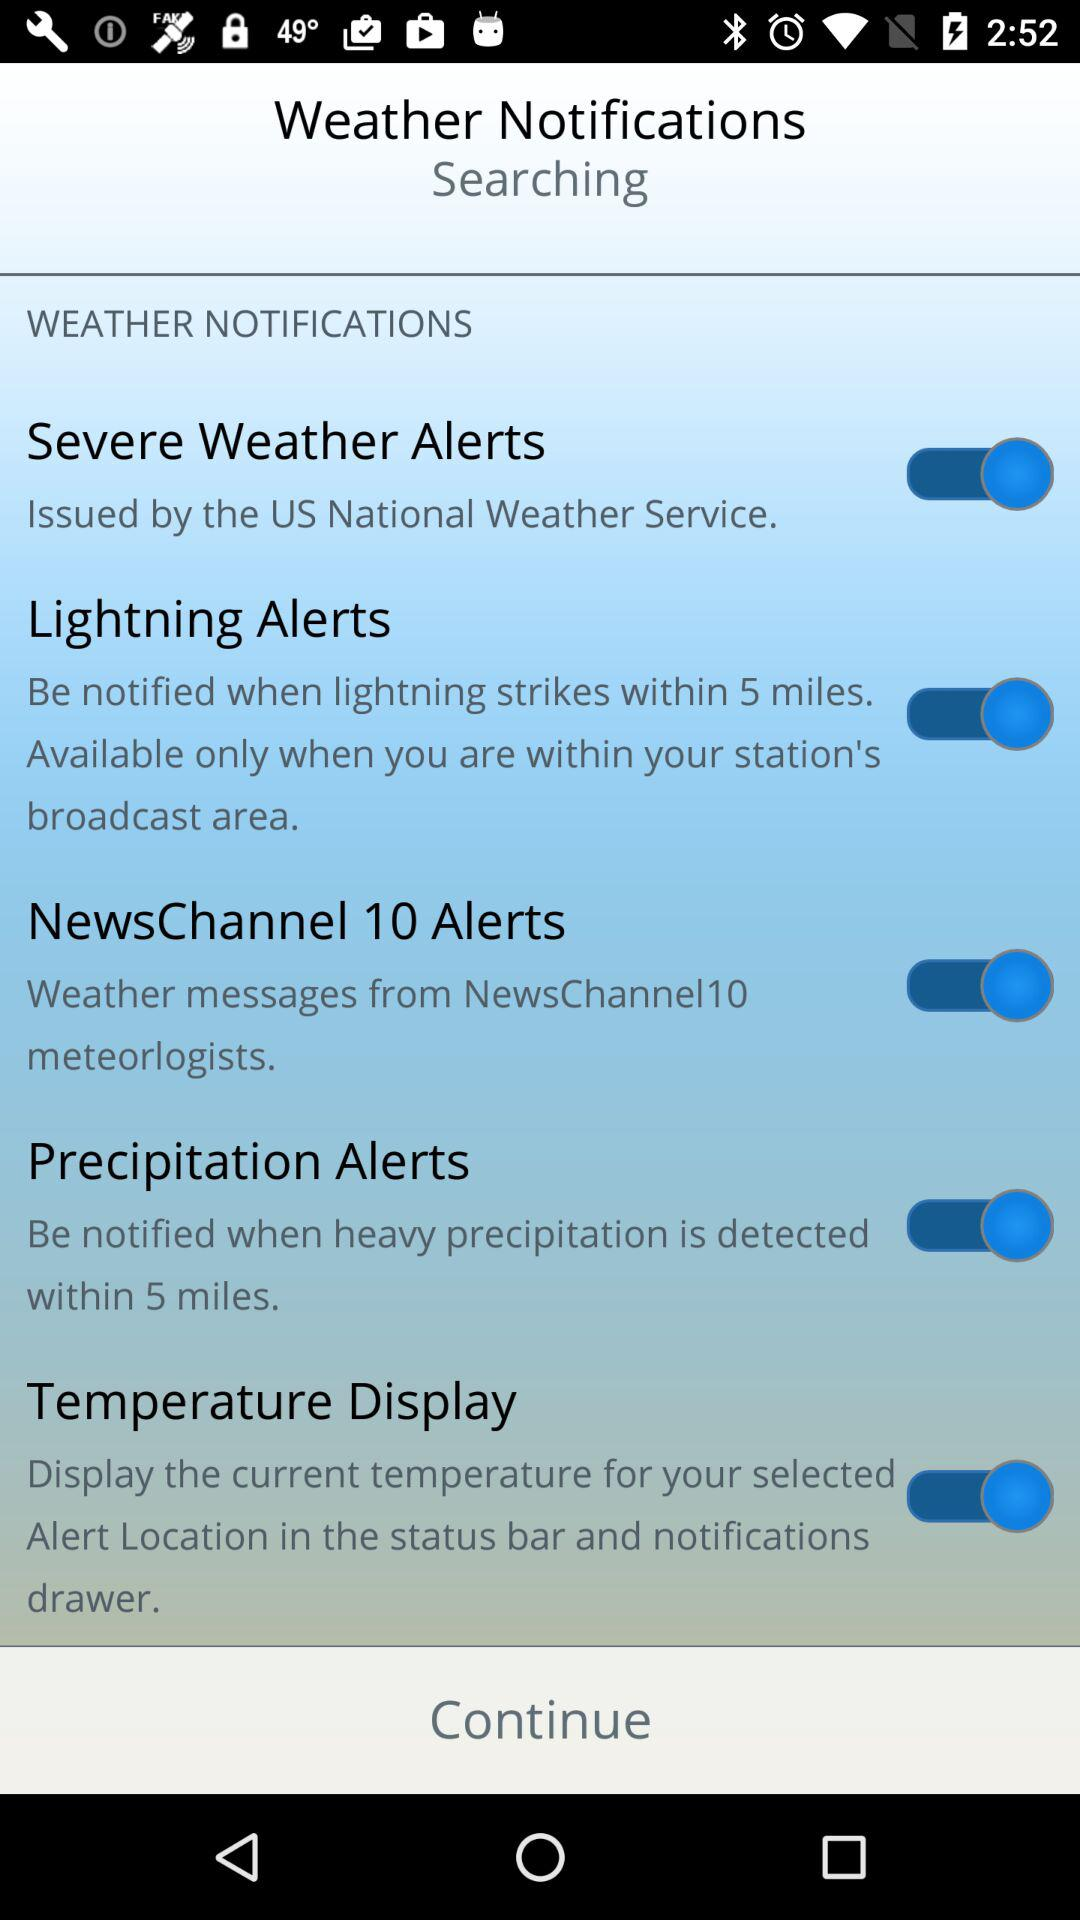What is the status of "Lightning Alerts"? The status is "on". 